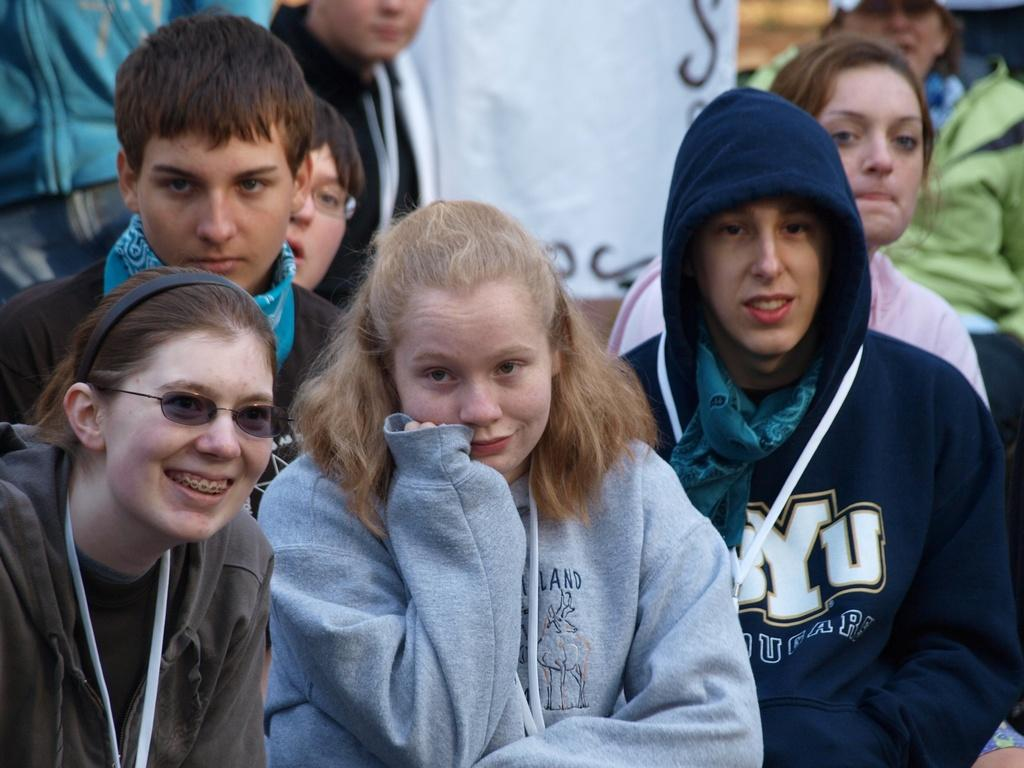How many people are in the image? There is a group of people in the image, but the exact number cannot be determined without more information. What are the people in the image doing? The provided facts do not specify what the people are doing in the image. Can you describe the setting or location of the image? The provided facts do not give any information about the setting or location of the image. What type of yak can be seen in the image? There is no yak present in the image. What degree of difficulty is the surprise in the image rated? There is no surprise or degree of difficulty mentioned in the image. 